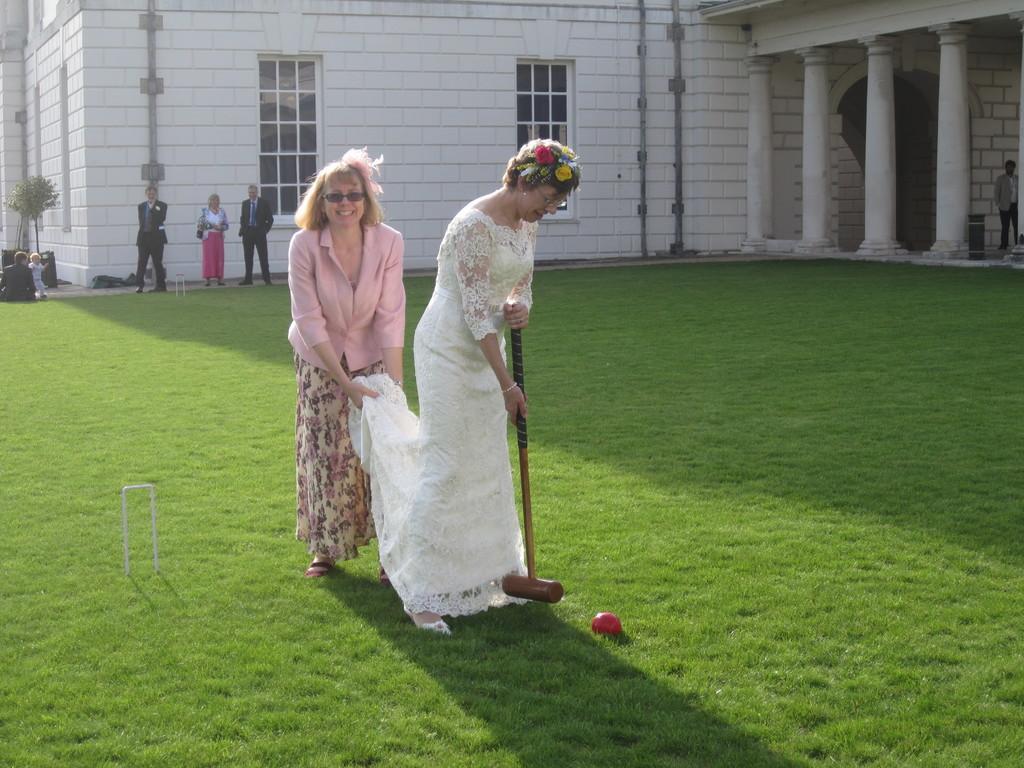Could you give a brief overview of what you see in this image? In this image we can see two women wearing the glasses and standing on the grass. We can also see the woman who is wearing the white frock is holding an object. Image also consists of a ball, building with windows and pillars. In the background, we can see a few persons. We can also see the plant. 